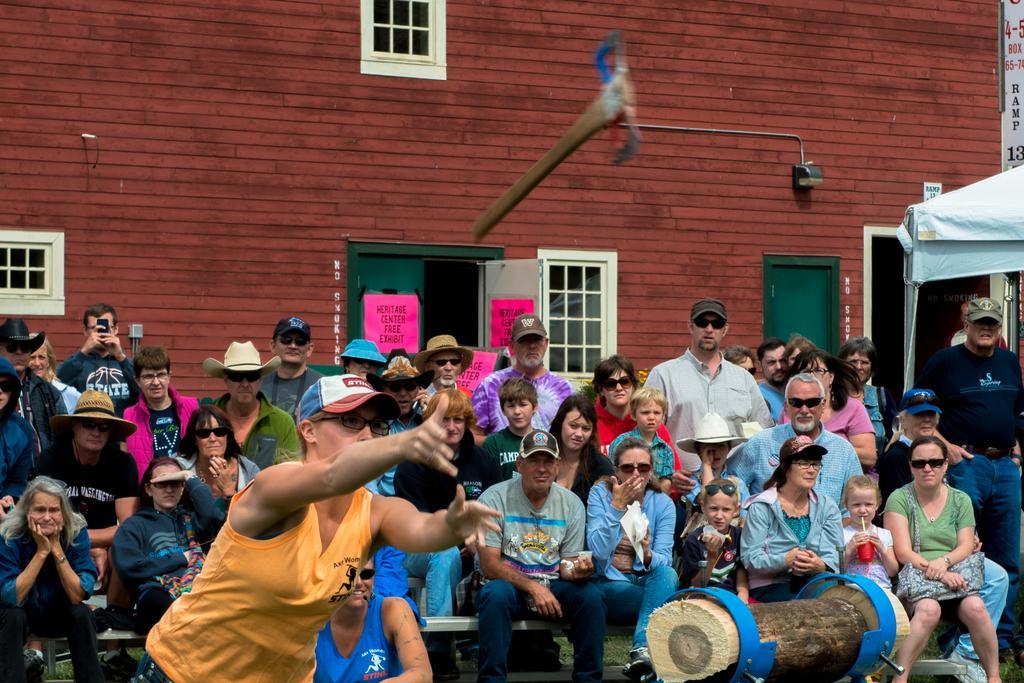How would you summarize this image in a sentence or two? In this picture there is a group of men and women sitting and watching the show. In the front there is a woman wearing yellow top is throwing the axe in the air. Behind there is a red color brick building with white window and doors. 